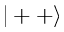<formula> <loc_0><loc_0><loc_500><loc_500>| + + \rangle</formula> 